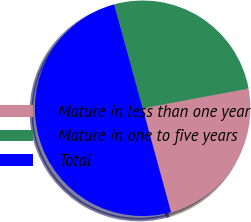Convert chart to OTSL. <chart><loc_0><loc_0><loc_500><loc_500><pie_chart><fcel>Mature in less than one year<fcel>Mature in one to five years<fcel>Total<nl><fcel>23.7%<fcel>26.33%<fcel>49.97%<nl></chart> 